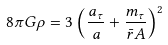<formula> <loc_0><loc_0><loc_500><loc_500>8 \pi G \rho = 3 \left ( \frac { a _ { \tau } } { a } + \frac { m _ { \tau } } { \bar { r } A } \right ) ^ { 2 }</formula> 